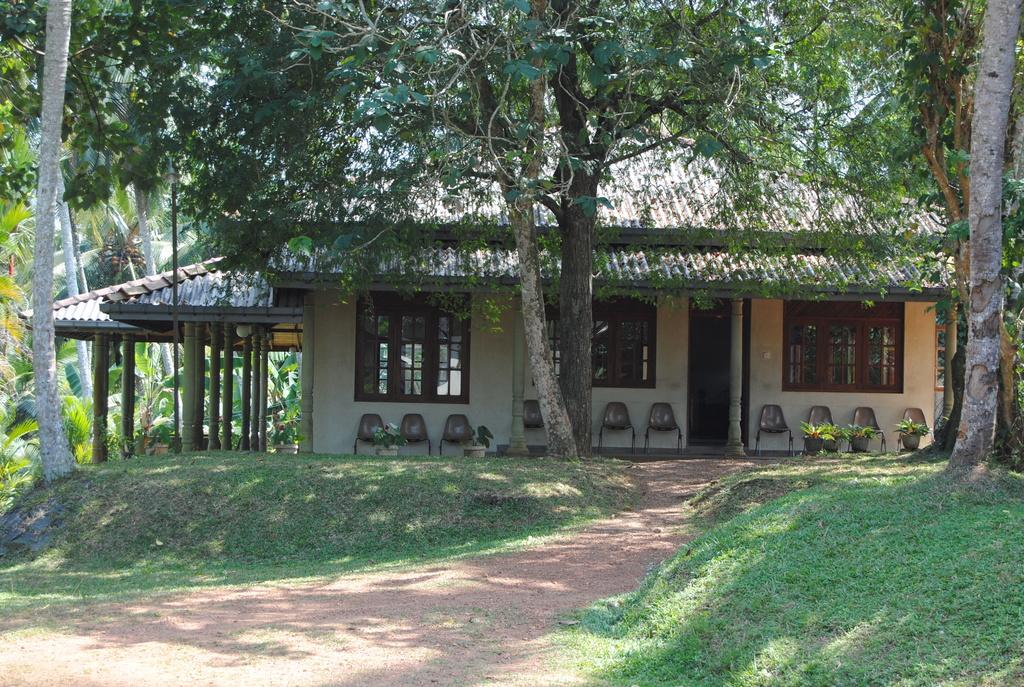What can be seen in the foreground of the image? There is a path to walk in the foreground of the image. What type of vegetation is on the right side of the image? There is grass on the right side of the image. What else can be seen on the right side of the image? There are trees on the right side of the image. What is located in the background of the image? There is a hut, chairs, trees, and flower pots in the background of the image. What type of cave can be seen in the image? There is no cave present in the image. Can you list all the items that are used for sitting in the image? The image does not show any items specifically used for sitting, only chairs are mentioned. 